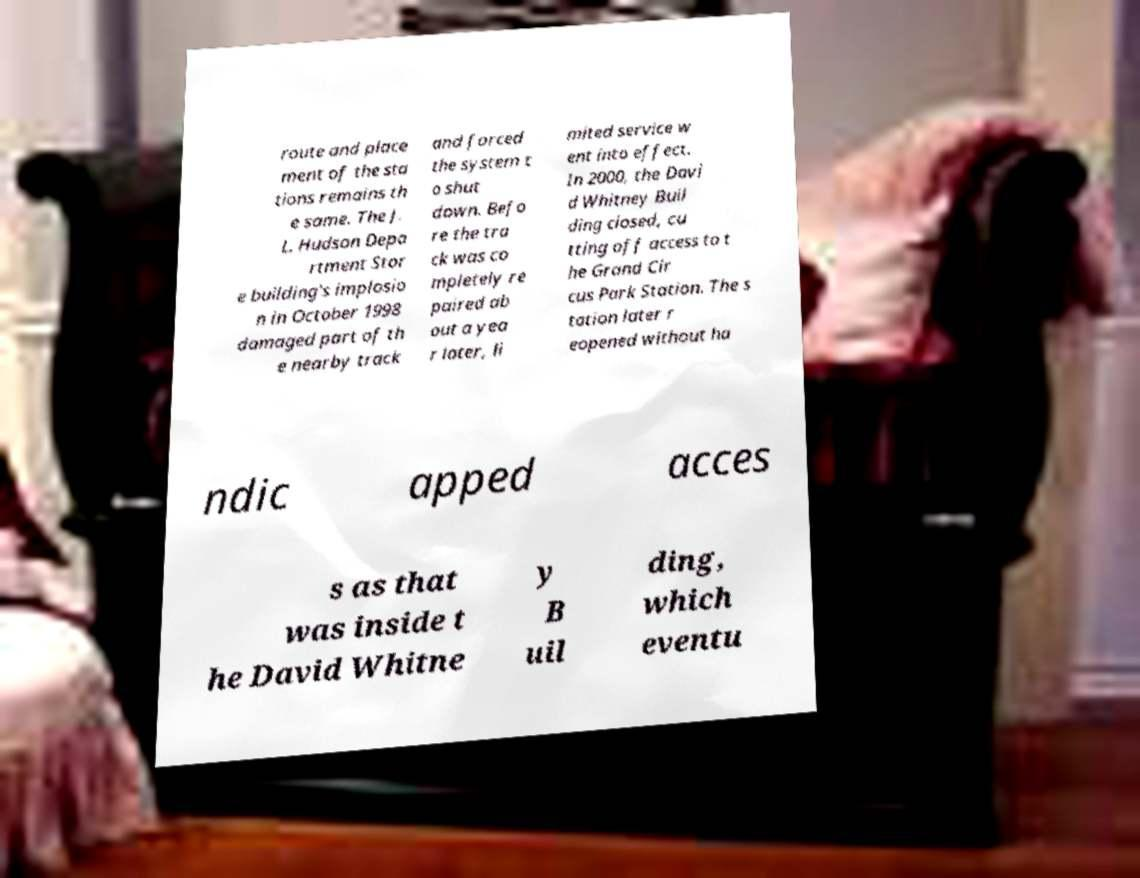There's text embedded in this image that I need extracted. Can you transcribe it verbatim? route and place ment of the sta tions remains th e same. The J. L. Hudson Depa rtment Stor e building's implosio n in October 1998 damaged part of th e nearby track and forced the system t o shut down. Befo re the tra ck was co mpletely re paired ab out a yea r later, li mited service w ent into effect. In 2000, the Davi d Whitney Buil ding closed, cu tting off access to t he Grand Cir cus Park Station. The s tation later r eopened without ha ndic apped acces s as that was inside t he David Whitne y B uil ding, which eventu 